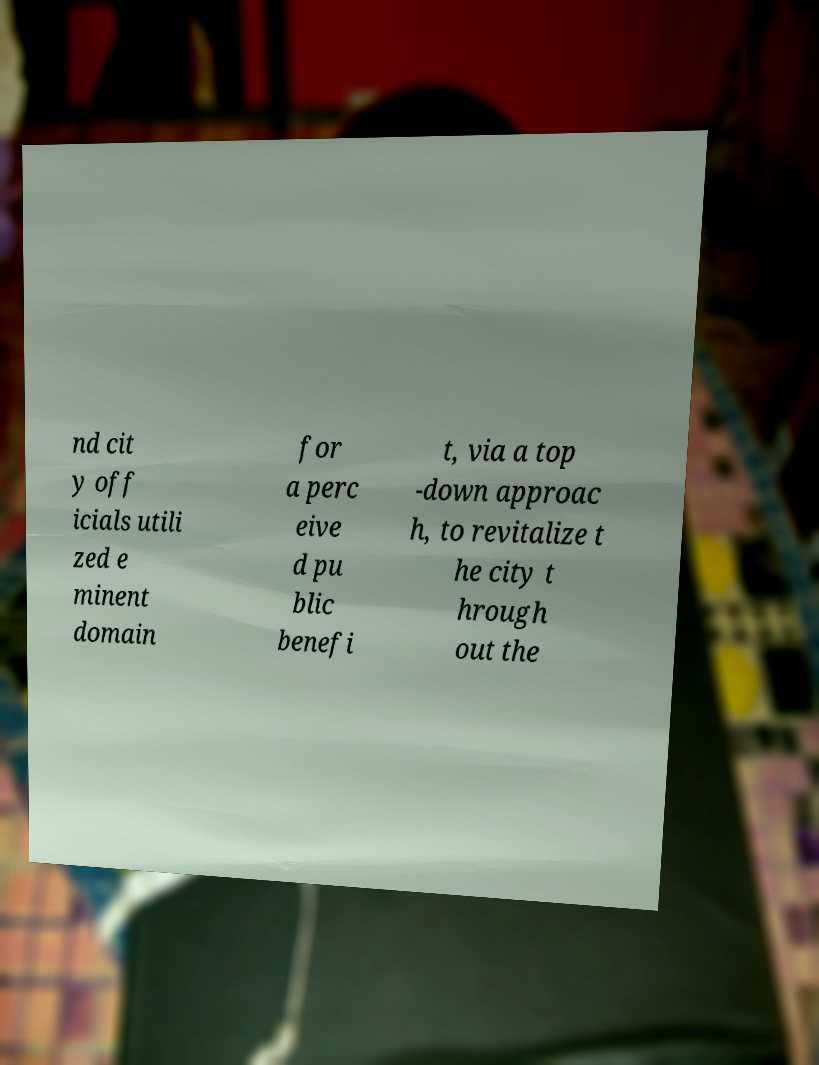For documentation purposes, I need the text within this image transcribed. Could you provide that? nd cit y off icials utili zed e minent domain for a perc eive d pu blic benefi t, via a top -down approac h, to revitalize t he city t hrough out the 